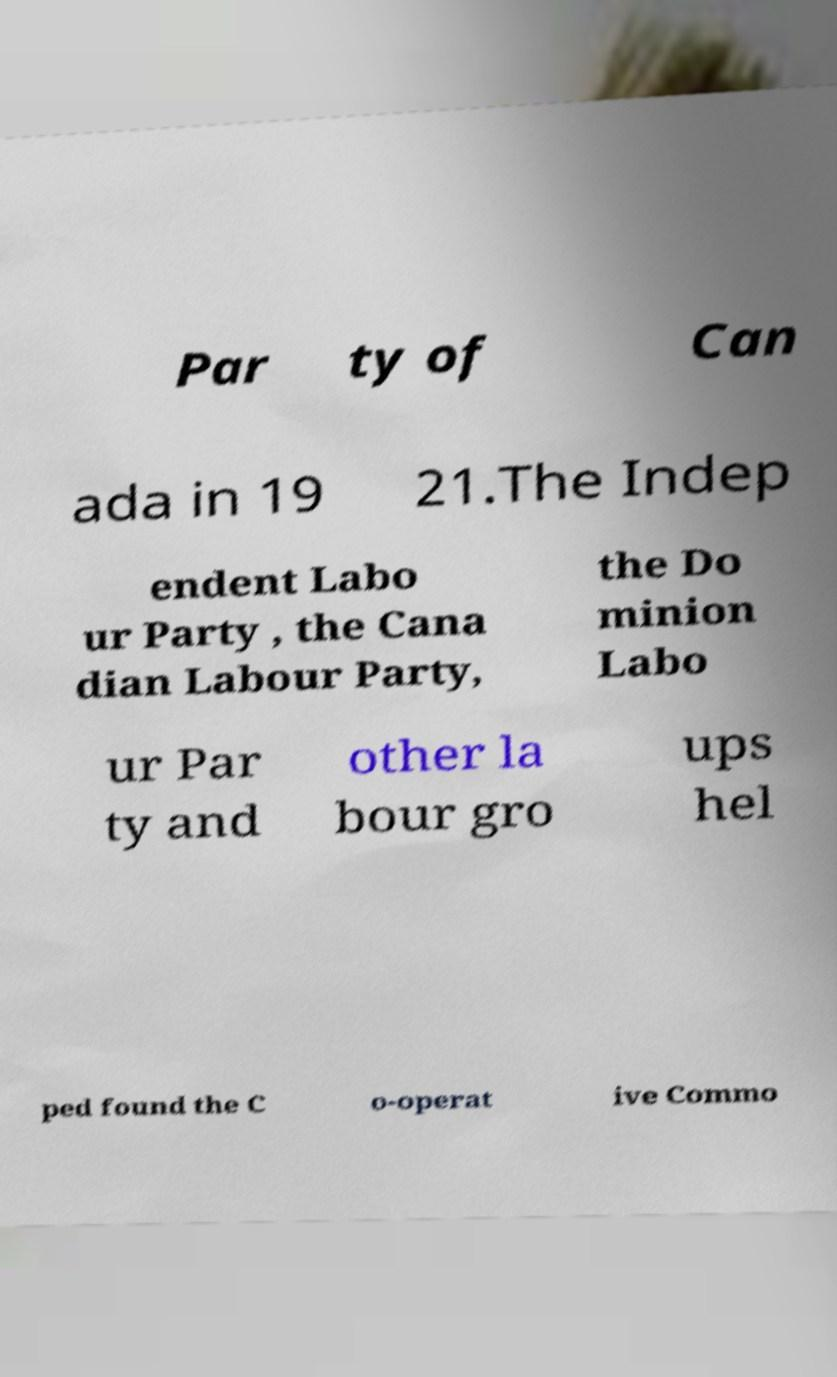I need the written content from this picture converted into text. Can you do that? Par ty of Can ada in 19 21.The Indep endent Labo ur Party , the Cana dian Labour Party, the Do minion Labo ur Par ty and other la bour gro ups hel ped found the C o-operat ive Commo 